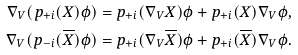Convert formula to latex. <formula><loc_0><loc_0><loc_500><loc_500>\nabla _ { V } ( p _ { + i } ( X ) \phi ) & = p _ { + i } ( \nabla _ { V } X ) \phi + p _ { + i } ( X ) \nabla _ { V } \phi , \\ \nabla _ { V } ( p _ { - i } ( \overline { X } ) \phi ) & = p _ { + i } ( \nabla _ { V } \overline { X } ) \phi + p _ { + i } ( \overline { X } ) \nabla _ { V } \phi . \\</formula> 